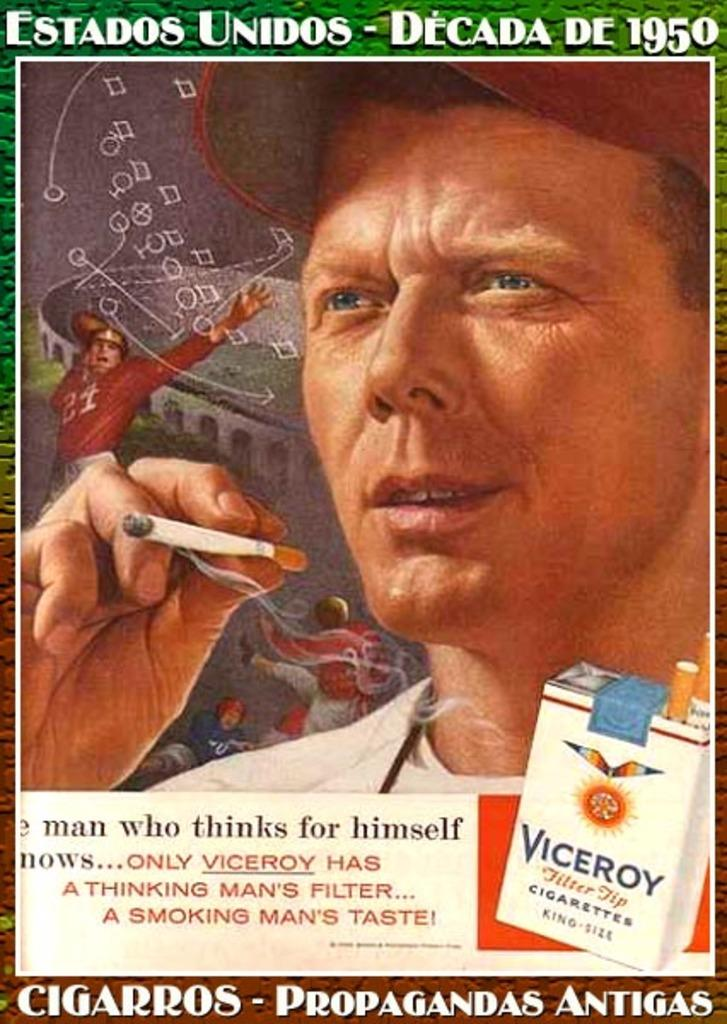What is featured in the image along with the person? There is a poster in the image. What is the person holding in the image? The person is holding a cigarette. Is there any indication of where the person might have obtained the cigarette? Yes, there is a cigarette box in the image. What can be found at the bottom of the image? There is text written at the bottom of the image. How many sisters does the person in the image have? There is no information about the person's sisters in the image. Can you describe the steam coming from the person's cigarette in the image? There is no steam visible in the image; the person is holding a cigarette but not smoking it. 